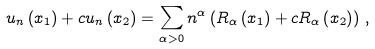Convert formula to latex. <formula><loc_0><loc_0><loc_500><loc_500>u _ { n } \left ( x _ { 1 } \right ) + c u _ { n } \left ( x _ { 2 } \right ) = \sum _ { \alpha > 0 } n ^ { \alpha } \left ( R _ { \alpha } \left ( x _ { 1 } \right ) + c R _ { \alpha } \left ( x _ { 2 } \right ) \right ) \, ,</formula> 